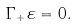Convert formula to latex. <formula><loc_0><loc_0><loc_500><loc_500>\Gamma _ { + } \varepsilon = 0 .</formula> 